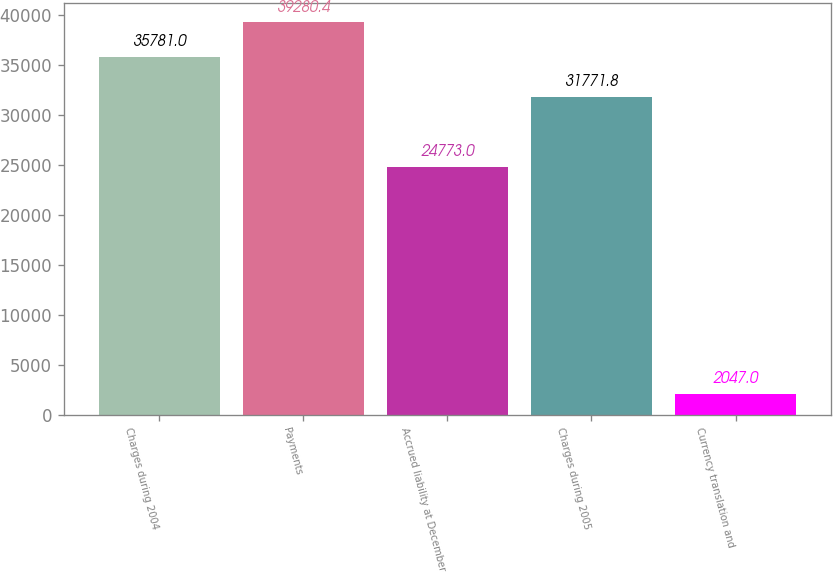Convert chart. <chart><loc_0><loc_0><loc_500><loc_500><bar_chart><fcel>Charges during 2004<fcel>Payments<fcel>Accrued liability at December<fcel>Charges during 2005<fcel>Currency translation and<nl><fcel>35781<fcel>39280.4<fcel>24773<fcel>31771.8<fcel>2047<nl></chart> 